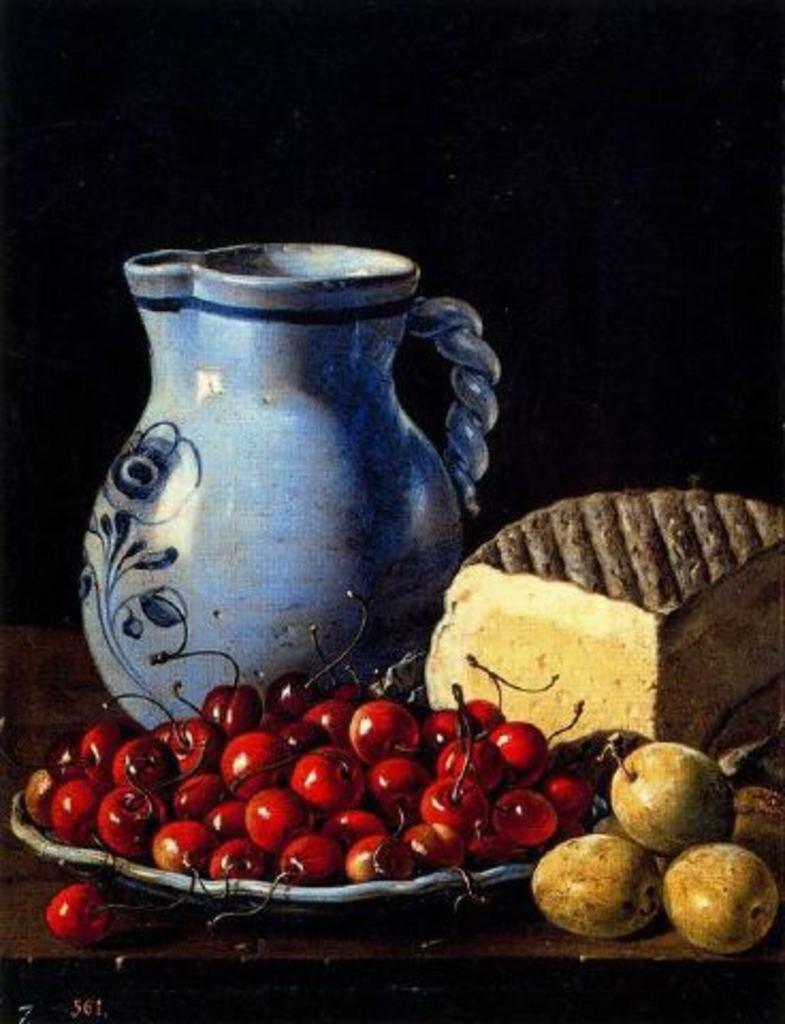How would you summarize this image in a sentence or two? In the center of the image there is a jar. There are fruits in the plate. There is a cake. 